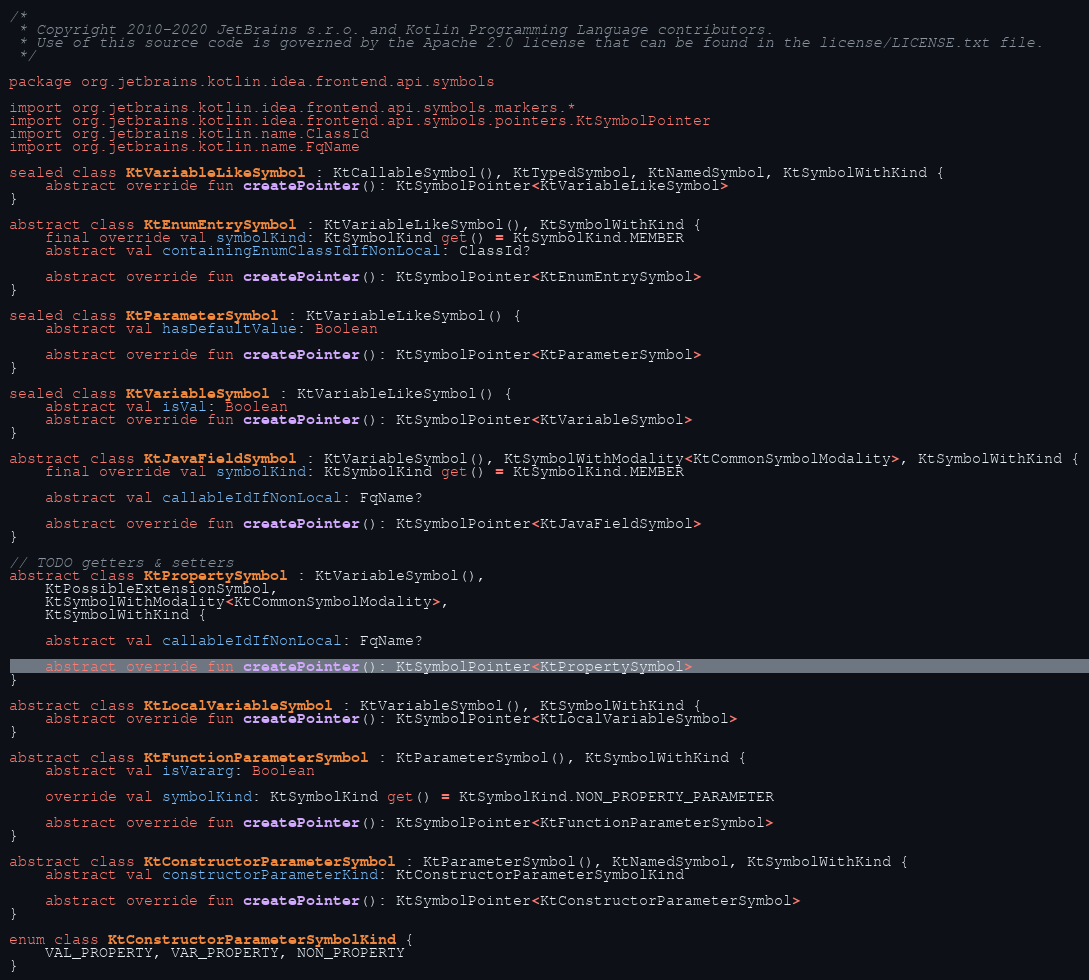<code> <loc_0><loc_0><loc_500><loc_500><_Kotlin_>/*
 * Copyright 2010-2020 JetBrains s.r.o. and Kotlin Programming Language contributors.
 * Use of this source code is governed by the Apache 2.0 license that can be found in the license/LICENSE.txt file.
 */

package org.jetbrains.kotlin.idea.frontend.api.symbols

import org.jetbrains.kotlin.idea.frontend.api.symbols.markers.*
import org.jetbrains.kotlin.idea.frontend.api.symbols.pointers.KtSymbolPointer
import org.jetbrains.kotlin.name.ClassId
import org.jetbrains.kotlin.name.FqName

sealed class KtVariableLikeSymbol : KtCallableSymbol(), KtTypedSymbol, KtNamedSymbol, KtSymbolWithKind {
    abstract override fun createPointer(): KtSymbolPointer<KtVariableLikeSymbol>
}

abstract class KtEnumEntrySymbol : KtVariableLikeSymbol(), KtSymbolWithKind {
    final override val symbolKind: KtSymbolKind get() = KtSymbolKind.MEMBER
    abstract val containingEnumClassIdIfNonLocal: ClassId?

    abstract override fun createPointer(): KtSymbolPointer<KtEnumEntrySymbol>
}

sealed class KtParameterSymbol : KtVariableLikeSymbol() {
    abstract val hasDefaultValue: Boolean

    abstract override fun createPointer(): KtSymbolPointer<KtParameterSymbol>
}

sealed class KtVariableSymbol : KtVariableLikeSymbol() {
    abstract val isVal: Boolean
    abstract override fun createPointer(): KtSymbolPointer<KtVariableSymbol>
}

abstract class KtJavaFieldSymbol : KtVariableSymbol(), KtSymbolWithModality<KtCommonSymbolModality>, KtSymbolWithKind {
    final override val symbolKind: KtSymbolKind get() = KtSymbolKind.MEMBER

    abstract val callableIdIfNonLocal: FqName?

    abstract override fun createPointer(): KtSymbolPointer<KtJavaFieldSymbol>
}

// TODO getters & setters
abstract class KtPropertySymbol : KtVariableSymbol(),
    KtPossibleExtensionSymbol,
    KtSymbolWithModality<KtCommonSymbolModality>,
    KtSymbolWithKind {

    abstract val callableIdIfNonLocal: FqName?

    abstract override fun createPointer(): KtSymbolPointer<KtPropertySymbol>
}

abstract class KtLocalVariableSymbol : KtVariableSymbol(), KtSymbolWithKind {
    abstract override fun createPointer(): KtSymbolPointer<KtLocalVariableSymbol>
}

abstract class KtFunctionParameterSymbol : KtParameterSymbol(), KtSymbolWithKind {
    abstract val isVararg: Boolean

    override val symbolKind: KtSymbolKind get() = KtSymbolKind.NON_PROPERTY_PARAMETER

    abstract override fun createPointer(): KtSymbolPointer<KtFunctionParameterSymbol>
}

abstract class KtConstructorParameterSymbol : KtParameterSymbol(), KtNamedSymbol, KtSymbolWithKind {
    abstract val constructorParameterKind: KtConstructorParameterSymbolKind

    abstract override fun createPointer(): KtSymbolPointer<KtConstructorParameterSymbol>
}

enum class KtConstructorParameterSymbolKind {
    VAL_PROPERTY, VAR_PROPERTY, NON_PROPERTY
}</code> 